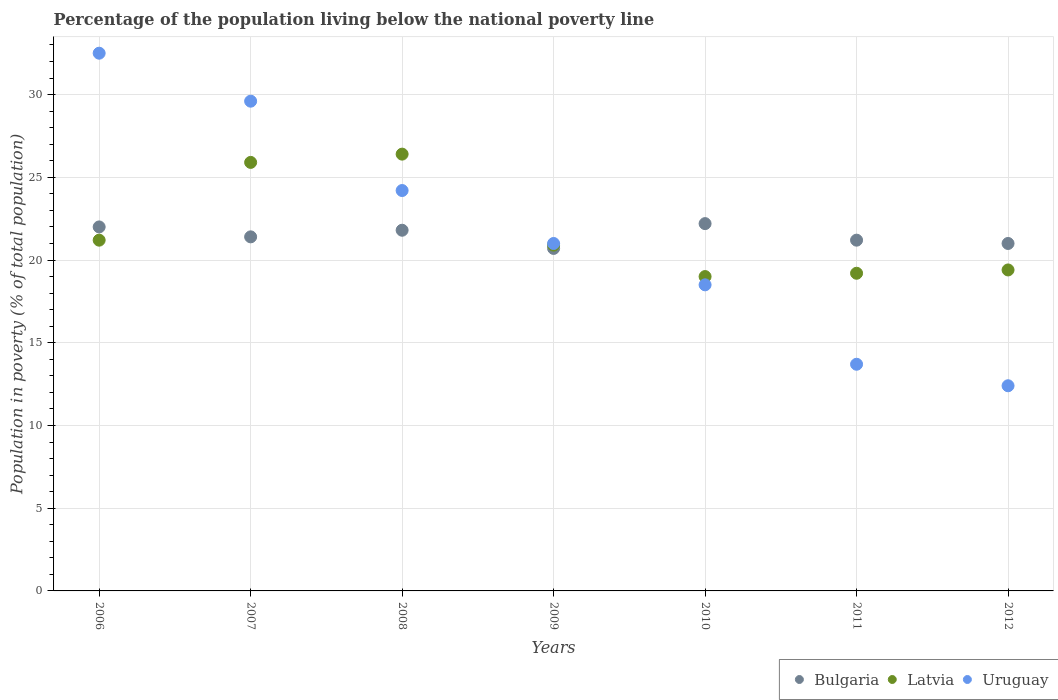What is the percentage of the population living below the national poverty line in Bulgaria in 2008?
Ensure brevity in your answer.  21.8. Across all years, what is the maximum percentage of the population living below the national poverty line in Bulgaria?
Make the answer very short. 22.2. In which year was the percentage of the population living below the national poverty line in Bulgaria maximum?
Provide a succinct answer. 2010. What is the total percentage of the population living below the national poverty line in Latvia in the graph?
Offer a very short reply. 152. What is the difference between the percentage of the population living below the national poverty line in Uruguay in 2007 and that in 2010?
Give a very brief answer. 11.1. What is the difference between the percentage of the population living below the national poverty line in Bulgaria in 2011 and the percentage of the population living below the national poverty line in Uruguay in 2007?
Offer a very short reply. -8.4. What is the average percentage of the population living below the national poverty line in Uruguay per year?
Offer a terse response. 21.7. In the year 2009, what is the difference between the percentage of the population living below the national poverty line in Latvia and percentage of the population living below the national poverty line in Bulgaria?
Keep it short and to the point. 0.2. What is the ratio of the percentage of the population living below the national poverty line in Uruguay in 2008 to that in 2012?
Provide a succinct answer. 1.95. What is the difference between the highest and the second highest percentage of the population living below the national poverty line in Uruguay?
Your answer should be compact. 2.9. What is the difference between the highest and the lowest percentage of the population living below the national poverty line in Uruguay?
Provide a succinct answer. 20.1. In how many years, is the percentage of the population living below the national poverty line in Uruguay greater than the average percentage of the population living below the national poverty line in Uruguay taken over all years?
Your answer should be compact. 3. Is it the case that in every year, the sum of the percentage of the population living below the national poverty line in Latvia and percentage of the population living below the national poverty line in Bulgaria  is greater than the percentage of the population living below the national poverty line in Uruguay?
Provide a succinct answer. Yes. Is the percentage of the population living below the national poverty line in Uruguay strictly less than the percentage of the population living below the national poverty line in Bulgaria over the years?
Ensure brevity in your answer.  No. How many dotlines are there?
Provide a succinct answer. 3. What is the difference between two consecutive major ticks on the Y-axis?
Your response must be concise. 5. Are the values on the major ticks of Y-axis written in scientific E-notation?
Make the answer very short. No. Where does the legend appear in the graph?
Offer a very short reply. Bottom right. How many legend labels are there?
Your answer should be very brief. 3. How are the legend labels stacked?
Offer a very short reply. Horizontal. What is the title of the graph?
Your answer should be compact. Percentage of the population living below the national poverty line. Does "South Asia" appear as one of the legend labels in the graph?
Provide a short and direct response. No. What is the label or title of the X-axis?
Keep it short and to the point. Years. What is the label or title of the Y-axis?
Offer a very short reply. Population in poverty (% of total population). What is the Population in poverty (% of total population) of Bulgaria in 2006?
Keep it short and to the point. 22. What is the Population in poverty (% of total population) of Latvia in 2006?
Keep it short and to the point. 21.2. What is the Population in poverty (% of total population) of Uruguay in 2006?
Ensure brevity in your answer.  32.5. What is the Population in poverty (% of total population) in Bulgaria in 2007?
Your response must be concise. 21.4. What is the Population in poverty (% of total population) in Latvia in 2007?
Offer a terse response. 25.9. What is the Population in poverty (% of total population) in Uruguay in 2007?
Ensure brevity in your answer.  29.6. What is the Population in poverty (% of total population) of Bulgaria in 2008?
Provide a short and direct response. 21.8. What is the Population in poverty (% of total population) in Latvia in 2008?
Your answer should be very brief. 26.4. What is the Population in poverty (% of total population) of Uruguay in 2008?
Give a very brief answer. 24.2. What is the Population in poverty (% of total population) in Bulgaria in 2009?
Keep it short and to the point. 20.7. What is the Population in poverty (% of total population) in Latvia in 2009?
Your answer should be very brief. 20.9. What is the Population in poverty (% of total population) in Bulgaria in 2010?
Ensure brevity in your answer.  22.2. What is the Population in poverty (% of total population) of Latvia in 2010?
Your answer should be compact. 19. What is the Population in poverty (% of total population) in Uruguay in 2010?
Give a very brief answer. 18.5. What is the Population in poverty (% of total population) in Bulgaria in 2011?
Your answer should be compact. 21.2. What is the Population in poverty (% of total population) in Uruguay in 2012?
Offer a terse response. 12.4. Across all years, what is the maximum Population in poverty (% of total population) in Bulgaria?
Your answer should be compact. 22.2. Across all years, what is the maximum Population in poverty (% of total population) in Latvia?
Keep it short and to the point. 26.4. Across all years, what is the maximum Population in poverty (% of total population) in Uruguay?
Offer a very short reply. 32.5. Across all years, what is the minimum Population in poverty (% of total population) of Bulgaria?
Ensure brevity in your answer.  20.7. Across all years, what is the minimum Population in poverty (% of total population) of Latvia?
Offer a very short reply. 19. Across all years, what is the minimum Population in poverty (% of total population) in Uruguay?
Make the answer very short. 12.4. What is the total Population in poverty (% of total population) in Bulgaria in the graph?
Offer a very short reply. 150.3. What is the total Population in poverty (% of total population) in Latvia in the graph?
Provide a succinct answer. 152. What is the total Population in poverty (% of total population) in Uruguay in the graph?
Make the answer very short. 151.9. What is the difference between the Population in poverty (% of total population) of Latvia in 2006 and that in 2007?
Give a very brief answer. -4.7. What is the difference between the Population in poverty (% of total population) of Bulgaria in 2006 and that in 2008?
Keep it short and to the point. 0.2. What is the difference between the Population in poverty (% of total population) in Uruguay in 2006 and that in 2008?
Make the answer very short. 8.3. What is the difference between the Population in poverty (% of total population) in Bulgaria in 2006 and that in 2010?
Provide a succinct answer. -0.2. What is the difference between the Population in poverty (% of total population) in Latvia in 2006 and that in 2011?
Ensure brevity in your answer.  2. What is the difference between the Population in poverty (% of total population) in Uruguay in 2006 and that in 2011?
Keep it short and to the point. 18.8. What is the difference between the Population in poverty (% of total population) of Latvia in 2006 and that in 2012?
Offer a very short reply. 1.8. What is the difference between the Population in poverty (% of total population) in Uruguay in 2006 and that in 2012?
Provide a short and direct response. 20.1. What is the difference between the Population in poverty (% of total population) in Uruguay in 2007 and that in 2008?
Keep it short and to the point. 5.4. What is the difference between the Population in poverty (% of total population) of Latvia in 2007 and that in 2009?
Your answer should be very brief. 5. What is the difference between the Population in poverty (% of total population) in Uruguay in 2007 and that in 2009?
Your answer should be very brief. 8.6. What is the difference between the Population in poverty (% of total population) in Bulgaria in 2007 and that in 2010?
Your answer should be very brief. -0.8. What is the difference between the Population in poverty (% of total population) of Latvia in 2007 and that in 2010?
Offer a very short reply. 6.9. What is the difference between the Population in poverty (% of total population) in Uruguay in 2007 and that in 2010?
Keep it short and to the point. 11.1. What is the difference between the Population in poverty (% of total population) of Bulgaria in 2007 and that in 2011?
Make the answer very short. 0.2. What is the difference between the Population in poverty (% of total population) in Uruguay in 2007 and that in 2012?
Offer a very short reply. 17.2. What is the difference between the Population in poverty (% of total population) of Latvia in 2008 and that in 2009?
Keep it short and to the point. 5.5. What is the difference between the Population in poverty (% of total population) in Bulgaria in 2008 and that in 2010?
Provide a succinct answer. -0.4. What is the difference between the Population in poverty (% of total population) of Latvia in 2008 and that in 2010?
Your answer should be compact. 7.4. What is the difference between the Population in poverty (% of total population) in Bulgaria in 2008 and that in 2011?
Your answer should be compact. 0.6. What is the difference between the Population in poverty (% of total population) of Bulgaria in 2008 and that in 2012?
Make the answer very short. 0.8. What is the difference between the Population in poverty (% of total population) of Latvia in 2008 and that in 2012?
Ensure brevity in your answer.  7. What is the difference between the Population in poverty (% of total population) of Latvia in 2009 and that in 2010?
Provide a short and direct response. 1.9. What is the difference between the Population in poverty (% of total population) of Uruguay in 2009 and that in 2010?
Provide a succinct answer. 2.5. What is the difference between the Population in poverty (% of total population) of Bulgaria in 2009 and that in 2011?
Ensure brevity in your answer.  -0.5. What is the difference between the Population in poverty (% of total population) of Latvia in 2009 and that in 2011?
Provide a succinct answer. 1.7. What is the difference between the Population in poverty (% of total population) of Latvia in 2009 and that in 2012?
Your answer should be compact. 1.5. What is the difference between the Population in poverty (% of total population) of Bulgaria in 2010 and that in 2012?
Ensure brevity in your answer.  1.2. What is the difference between the Population in poverty (% of total population) of Uruguay in 2010 and that in 2012?
Your answer should be compact. 6.1. What is the difference between the Population in poverty (% of total population) in Bulgaria in 2011 and that in 2012?
Your response must be concise. 0.2. What is the difference between the Population in poverty (% of total population) in Uruguay in 2011 and that in 2012?
Give a very brief answer. 1.3. What is the difference between the Population in poverty (% of total population) in Bulgaria in 2006 and the Population in poverty (% of total population) in Uruguay in 2007?
Give a very brief answer. -7.6. What is the difference between the Population in poverty (% of total population) of Latvia in 2006 and the Population in poverty (% of total population) of Uruguay in 2007?
Give a very brief answer. -8.4. What is the difference between the Population in poverty (% of total population) in Latvia in 2006 and the Population in poverty (% of total population) in Uruguay in 2008?
Offer a terse response. -3. What is the difference between the Population in poverty (% of total population) in Bulgaria in 2006 and the Population in poverty (% of total population) in Latvia in 2010?
Ensure brevity in your answer.  3. What is the difference between the Population in poverty (% of total population) of Bulgaria in 2006 and the Population in poverty (% of total population) of Uruguay in 2010?
Provide a succinct answer. 3.5. What is the difference between the Population in poverty (% of total population) of Latvia in 2006 and the Population in poverty (% of total population) of Uruguay in 2010?
Your answer should be compact. 2.7. What is the difference between the Population in poverty (% of total population) of Bulgaria in 2006 and the Population in poverty (% of total population) of Latvia in 2011?
Your answer should be compact. 2.8. What is the difference between the Population in poverty (% of total population) in Bulgaria in 2006 and the Population in poverty (% of total population) in Uruguay in 2011?
Offer a terse response. 8.3. What is the difference between the Population in poverty (% of total population) of Latvia in 2006 and the Population in poverty (% of total population) of Uruguay in 2011?
Give a very brief answer. 7.5. What is the difference between the Population in poverty (% of total population) of Bulgaria in 2006 and the Population in poverty (% of total population) of Latvia in 2012?
Offer a very short reply. 2.6. What is the difference between the Population in poverty (% of total population) of Bulgaria in 2007 and the Population in poverty (% of total population) of Latvia in 2008?
Offer a very short reply. -5. What is the difference between the Population in poverty (% of total population) of Bulgaria in 2007 and the Population in poverty (% of total population) of Uruguay in 2008?
Ensure brevity in your answer.  -2.8. What is the difference between the Population in poverty (% of total population) in Latvia in 2007 and the Population in poverty (% of total population) in Uruguay in 2008?
Provide a short and direct response. 1.7. What is the difference between the Population in poverty (% of total population) in Bulgaria in 2007 and the Population in poverty (% of total population) in Latvia in 2009?
Your response must be concise. 0.5. What is the difference between the Population in poverty (% of total population) in Bulgaria in 2007 and the Population in poverty (% of total population) in Uruguay in 2010?
Provide a succinct answer. 2.9. What is the difference between the Population in poverty (% of total population) in Bulgaria in 2007 and the Population in poverty (% of total population) in Latvia in 2011?
Give a very brief answer. 2.2. What is the difference between the Population in poverty (% of total population) of Bulgaria in 2007 and the Population in poverty (% of total population) of Uruguay in 2011?
Offer a terse response. 7.7. What is the difference between the Population in poverty (% of total population) in Bulgaria in 2007 and the Population in poverty (% of total population) in Uruguay in 2012?
Keep it short and to the point. 9. What is the difference between the Population in poverty (% of total population) of Bulgaria in 2008 and the Population in poverty (% of total population) of Latvia in 2009?
Offer a very short reply. 0.9. What is the difference between the Population in poverty (% of total population) of Bulgaria in 2008 and the Population in poverty (% of total population) of Uruguay in 2009?
Provide a short and direct response. 0.8. What is the difference between the Population in poverty (% of total population) of Latvia in 2008 and the Population in poverty (% of total population) of Uruguay in 2009?
Offer a very short reply. 5.4. What is the difference between the Population in poverty (% of total population) in Bulgaria in 2008 and the Population in poverty (% of total population) in Latvia in 2010?
Provide a succinct answer. 2.8. What is the difference between the Population in poverty (% of total population) in Bulgaria in 2008 and the Population in poverty (% of total population) in Uruguay in 2011?
Your response must be concise. 8.1. What is the difference between the Population in poverty (% of total population) of Latvia in 2008 and the Population in poverty (% of total population) of Uruguay in 2011?
Offer a terse response. 12.7. What is the difference between the Population in poverty (% of total population) in Latvia in 2008 and the Population in poverty (% of total population) in Uruguay in 2012?
Make the answer very short. 14. What is the difference between the Population in poverty (% of total population) of Latvia in 2009 and the Population in poverty (% of total population) of Uruguay in 2010?
Your answer should be very brief. 2.4. What is the difference between the Population in poverty (% of total population) of Bulgaria in 2009 and the Population in poverty (% of total population) of Latvia in 2011?
Your answer should be compact. 1.5. What is the difference between the Population in poverty (% of total population) in Latvia in 2009 and the Population in poverty (% of total population) in Uruguay in 2011?
Make the answer very short. 7.2. What is the difference between the Population in poverty (% of total population) in Bulgaria in 2009 and the Population in poverty (% of total population) in Latvia in 2012?
Provide a short and direct response. 1.3. What is the difference between the Population in poverty (% of total population) of Latvia in 2009 and the Population in poverty (% of total population) of Uruguay in 2012?
Offer a very short reply. 8.5. What is the difference between the Population in poverty (% of total population) of Latvia in 2010 and the Population in poverty (% of total population) of Uruguay in 2011?
Provide a succinct answer. 5.3. What is the difference between the Population in poverty (% of total population) in Bulgaria in 2010 and the Population in poverty (% of total population) in Uruguay in 2012?
Your response must be concise. 9.8. What is the difference between the Population in poverty (% of total population) in Bulgaria in 2011 and the Population in poverty (% of total population) in Uruguay in 2012?
Ensure brevity in your answer.  8.8. What is the average Population in poverty (% of total population) of Bulgaria per year?
Provide a succinct answer. 21.47. What is the average Population in poverty (% of total population) of Latvia per year?
Make the answer very short. 21.71. What is the average Population in poverty (% of total population) of Uruguay per year?
Your answer should be very brief. 21.7. In the year 2006, what is the difference between the Population in poverty (% of total population) in Bulgaria and Population in poverty (% of total population) in Uruguay?
Ensure brevity in your answer.  -10.5. In the year 2007, what is the difference between the Population in poverty (% of total population) of Bulgaria and Population in poverty (% of total population) of Latvia?
Offer a terse response. -4.5. In the year 2007, what is the difference between the Population in poverty (% of total population) of Bulgaria and Population in poverty (% of total population) of Uruguay?
Offer a very short reply. -8.2. In the year 2007, what is the difference between the Population in poverty (% of total population) of Latvia and Population in poverty (% of total population) of Uruguay?
Ensure brevity in your answer.  -3.7. In the year 2008, what is the difference between the Population in poverty (% of total population) in Bulgaria and Population in poverty (% of total population) in Uruguay?
Your answer should be compact. -2.4. In the year 2008, what is the difference between the Population in poverty (% of total population) in Latvia and Population in poverty (% of total population) in Uruguay?
Offer a very short reply. 2.2. In the year 2009, what is the difference between the Population in poverty (% of total population) of Bulgaria and Population in poverty (% of total population) of Latvia?
Provide a succinct answer. -0.2. In the year 2010, what is the difference between the Population in poverty (% of total population) of Bulgaria and Population in poverty (% of total population) of Latvia?
Offer a very short reply. 3.2. In the year 2010, what is the difference between the Population in poverty (% of total population) in Bulgaria and Population in poverty (% of total population) in Uruguay?
Your answer should be very brief. 3.7. In the year 2011, what is the difference between the Population in poverty (% of total population) in Bulgaria and Population in poverty (% of total population) in Uruguay?
Provide a succinct answer. 7.5. In the year 2011, what is the difference between the Population in poverty (% of total population) in Latvia and Population in poverty (% of total population) in Uruguay?
Make the answer very short. 5.5. In the year 2012, what is the difference between the Population in poverty (% of total population) in Bulgaria and Population in poverty (% of total population) in Latvia?
Make the answer very short. 1.6. In the year 2012, what is the difference between the Population in poverty (% of total population) of Latvia and Population in poverty (% of total population) of Uruguay?
Provide a succinct answer. 7. What is the ratio of the Population in poverty (% of total population) of Bulgaria in 2006 to that in 2007?
Keep it short and to the point. 1.03. What is the ratio of the Population in poverty (% of total population) of Latvia in 2006 to that in 2007?
Give a very brief answer. 0.82. What is the ratio of the Population in poverty (% of total population) of Uruguay in 2006 to that in 2007?
Provide a succinct answer. 1.1. What is the ratio of the Population in poverty (% of total population) of Bulgaria in 2006 to that in 2008?
Your response must be concise. 1.01. What is the ratio of the Population in poverty (% of total population) of Latvia in 2006 to that in 2008?
Make the answer very short. 0.8. What is the ratio of the Population in poverty (% of total population) in Uruguay in 2006 to that in 2008?
Provide a short and direct response. 1.34. What is the ratio of the Population in poverty (% of total population) of Bulgaria in 2006 to that in 2009?
Provide a short and direct response. 1.06. What is the ratio of the Population in poverty (% of total population) in Latvia in 2006 to that in 2009?
Provide a short and direct response. 1.01. What is the ratio of the Population in poverty (% of total population) in Uruguay in 2006 to that in 2009?
Make the answer very short. 1.55. What is the ratio of the Population in poverty (% of total population) of Bulgaria in 2006 to that in 2010?
Provide a succinct answer. 0.99. What is the ratio of the Population in poverty (% of total population) in Latvia in 2006 to that in 2010?
Your answer should be very brief. 1.12. What is the ratio of the Population in poverty (% of total population) of Uruguay in 2006 to that in 2010?
Offer a very short reply. 1.76. What is the ratio of the Population in poverty (% of total population) of Bulgaria in 2006 to that in 2011?
Give a very brief answer. 1.04. What is the ratio of the Population in poverty (% of total population) in Latvia in 2006 to that in 2011?
Ensure brevity in your answer.  1.1. What is the ratio of the Population in poverty (% of total population) in Uruguay in 2006 to that in 2011?
Your answer should be compact. 2.37. What is the ratio of the Population in poverty (% of total population) of Bulgaria in 2006 to that in 2012?
Give a very brief answer. 1.05. What is the ratio of the Population in poverty (% of total population) of Latvia in 2006 to that in 2012?
Your answer should be compact. 1.09. What is the ratio of the Population in poverty (% of total population) of Uruguay in 2006 to that in 2012?
Offer a terse response. 2.62. What is the ratio of the Population in poverty (% of total population) in Bulgaria in 2007 to that in 2008?
Offer a terse response. 0.98. What is the ratio of the Population in poverty (% of total population) in Latvia in 2007 to that in 2008?
Your answer should be very brief. 0.98. What is the ratio of the Population in poverty (% of total population) in Uruguay in 2007 to that in 2008?
Your answer should be very brief. 1.22. What is the ratio of the Population in poverty (% of total population) of Bulgaria in 2007 to that in 2009?
Give a very brief answer. 1.03. What is the ratio of the Population in poverty (% of total population) of Latvia in 2007 to that in 2009?
Offer a very short reply. 1.24. What is the ratio of the Population in poverty (% of total population) in Uruguay in 2007 to that in 2009?
Offer a very short reply. 1.41. What is the ratio of the Population in poverty (% of total population) in Bulgaria in 2007 to that in 2010?
Make the answer very short. 0.96. What is the ratio of the Population in poverty (% of total population) of Latvia in 2007 to that in 2010?
Ensure brevity in your answer.  1.36. What is the ratio of the Population in poverty (% of total population) in Bulgaria in 2007 to that in 2011?
Your answer should be very brief. 1.01. What is the ratio of the Population in poverty (% of total population) in Latvia in 2007 to that in 2011?
Your answer should be compact. 1.35. What is the ratio of the Population in poverty (% of total population) of Uruguay in 2007 to that in 2011?
Your response must be concise. 2.16. What is the ratio of the Population in poverty (% of total population) of Latvia in 2007 to that in 2012?
Provide a short and direct response. 1.34. What is the ratio of the Population in poverty (% of total population) of Uruguay in 2007 to that in 2012?
Your response must be concise. 2.39. What is the ratio of the Population in poverty (% of total population) in Bulgaria in 2008 to that in 2009?
Your answer should be compact. 1.05. What is the ratio of the Population in poverty (% of total population) of Latvia in 2008 to that in 2009?
Ensure brevity in your answer.  1.26. What is the ratio of the Population in poverty (% of total population) of Uruguay in 2008 to that in 2009?
Your answer should be compact. 1.15. What is the ratio of the Population in poverty (% of total population) in Bulgaria in 2008 to that in 2010?
Offer a terse response. 0.98. What is the ratio of the Population in poverty (% of total population) in Latvia in 2008 to that in 2010?
Your answer should be very brief. 1.39. What is the ratio of the Population in poverty (% of total population) of Uruguay in 2008 to that in 2010?
Your response must be concise. 1.31. What is the ratio of the Population in poverty (% of total population) of Bulgaria in 2008 to that in 2011?
Your answer should be very brief. 1.03. What is the ratio of the Population in poverty (% of total population) in Latvia in 2008 to that in 2011?
Your answer should be very brief. 1.38. What is the ratio of the Population in poverty (% of total population) of Uruguay in 2008 to that in 2011?
Your answer should be compact. 1.77. What is the ratio of the Population in poverty (% of total population) of Bulgaria in 2008 to that in 2012?
Offer a very short reply. 1.04. What is the ratio of the Population in poverty (% of total population) of Latvia in 2008 to that in 2012?
Offer a terse response. 1.36. What is the ratio of the Population in poverty (% of total population) of Uruguay in 2008 to that in 2012?
Keep it short and to the point. 1.95. What is the ratio of the Population in poverty (% of total population) of Bulgaria in 2009 to that in 2010?
Give a very brief answer. 0.93. What is the ratio of the Population in poverty (% of total population) in Uruguay in 2009 to that in 2010?
Make the answer very short. 1.14. What is the ratio of the Population in poverty (% of total population) in Bulgaria in 2009 to that in 2011?
Provide a succinct answer. 0.98. What is the ratio of the Population in poverty (% of total population) of Latvia in 2009 to that in 2011?
Offer a terse response. 1.09. What is the ratio of the Population in poverty (% of total population) of Uruguay in 2009 to that in 2011?
Provide a short and direct response. 1.53. What is the ratio of the Population in poverty (% of total population) in Bulgaria in 2009 to that in 2012?
Provide a short and direct response. 0.99. What is the ratio of the Population in poverty (% of total population) of Latvia in 2009 to that in 2012?
Provide a short and direct response. 1.08. What is the ratio of the Population in poverty (% of total population) in Uruguay in 2009 to that in 2012?
Your answer should be compact. 1.69. What is the ratio of the Population in poverty (% of total population) in Bulgaria in 2010 to that in 2011?
Provide a succinct answer. 1.05. What is the ratio of the Population in poverty (% of total population) in Latvia in 2010 to that in 2011?
Provide a succinct answer. 0.99. What is the ratio of the Population in poverty (% of total population) of Uruguay in 2010 to that in 2011?
Offer a terse response. 1.35. What is the ratio of the Population in poverty (% of total population) in Bulgaria in 2010 to that in 2012?
Offer a terse response. 1.06. What is the ratio of the Population in poverty (% of total population) of Latvia in 2010 to that in 2012?
Offer a very short reply. 0.98. What is the ratio of the Population in poverty (% of total population) in Uruguay in 2010 to that in 2012?
Provide a short and direct response. 1.49. What is the ratio of the Population in poverty (% of total population) of Bulgaria in 2011 to that in 2012?
Offer a terse response. 1.01. What is the ratio of the Population in poverty (% of total population) of Latvia in 2011 to that in 2012?
Your answer should be very brief. 0.99. What is the ratio of the Population in poverty (% of total population) of Uruguay in 2011 to that in 2012?
Offer a terse response. 1.1. What is the difference between the highest and the second highest Population in poverty (% of total population) in Bulgaria?
Your answer should be compact. 0.2. What is the difference between the highest and the second highest Population in poverty (% of total population) in Uruguay?
Ensure brevity in your answer.  2.9. What is the difference between the highest and the lowest Population in poverty (% of total population) in Uruguay?
Provide a succinct answer. 20.1. 